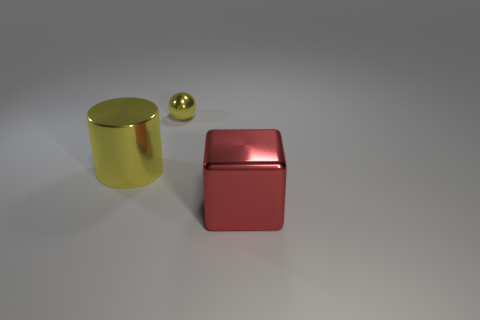Subtract all cylinders. How many objects are left? 2 Add 3 big brown rubber spheres. How many objects exist? 6 Add 1 yellow cylinders. How many yellow cylinders are left? 2 Add 3 shiny objects. How many shiny objects exist? 6 Subtract 0 brown blocks. How many objects are left? 3 Subtract all tiny balls. Subtract all big red things. How many objects are left? 1 